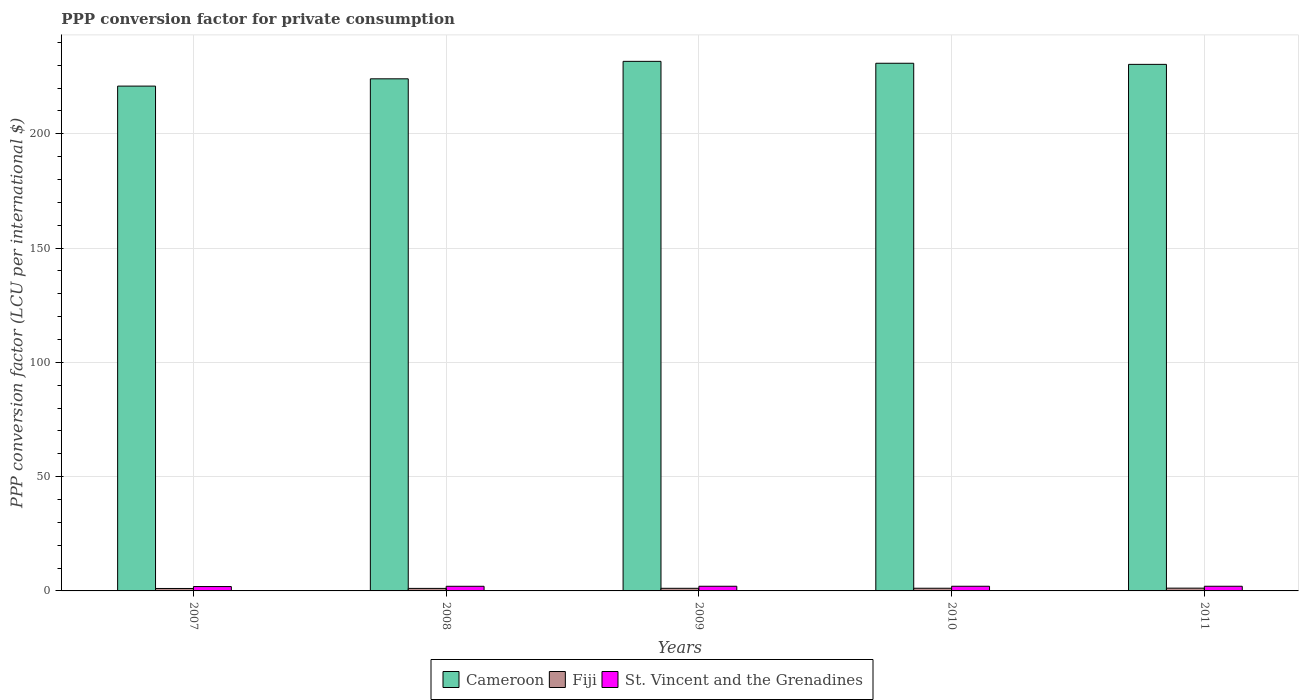How many different coloured bars are there?
Make the answer very short. 3. How many groups of bars are there?
Ensure brevity in your answer.  5. Are the number of bars per tick equal to the number of legend labels?
Provide a succinct answer. Yes. How many bars are there on the 2nd tick from the right?
Make the answer very short. 3. What is the label of the 3rd group of bars from the left?
Ensure brevity in your answer.  2009. What is the PPP conversion factor for private consumption in Fiji in 2011?
Offer a very short reply. 1.22. Across all years, what is the maximum PPP conversion factor for private consumption in Cameroon?
Offer a very short reply. 231.69. Across all years, what is the minimum PPP conversion factor for private consumption in Fiji?
Your answer should be compact. 1.07. In which year was the PPP conversion factor for private consumption in Cameroon minimum?
Provide a short and direct response. 2007. What is the total PPP conversion factor for private consumption in St. Vincent and the Grenadines in the graph?
Make the answer very short. 10.06. What is the difference between the PPP conversion factor for private consumption in Fiji in 2010 and that in 2011?
Your answer should be very brief. -0.05. What is the difference between the PPP conversion factor for private consumption in Fiji in 2008 and the PPP conversion factor for private consumption in Cameroon in 2010?
Give a very brief answer. -229.75. What is the average PPP conversion factor for private consumption in St. Vincent and the Grenadines per year?
Provide a succinct answer. 2.01. In the year 2008, what is the difference between the PPP conversion factor for private consumption in Cameroon and PPP conversion factor for private consumption in Fiji?
Make the answer very short. 222.94. What is the ratio of the PPP conversion factor for private consumption in St. Vincent and the Grenadines in 2010 to that in 2011?
Make the answer very short. 1. What is the difference between the highest and the second highest PPP conversion factor for private consumption in Cameroon?
Keep it short and to the point. 0.83. What is the difference between the highest and the lowest PPP conversion factor for private consumption in Cameroon?
Give a very brief answer. 10.83. In how many years, is the PPP conversion factor for private consumption in Fiji greater than the average PPP conversion factor for private consumption in Fiji taken over all years?
Ensure brevity in your answer.  3. What does the 1st bar from the left in 2010 represents?
Your answer should be compact. Cameroon. What does the 3rd bar from the right in 2011 represents?
Your answer should be compact. Cameroon. Are all the bars in the graph horizontal?
Provide a succinct answer. No. How many years are there in the graph?
Offer a very short reply. 5. Are the values on the major ticks of Y-axis written in scientific E-notation?
Your response must be concise. No. How are the legend labels stacked?
Offer a terse response. Horizontal. What is the title of the graph?
Keep it short and to the point. PPP conversion factor for private consumption. What is the label or title of the Y-axis?
Give a very brief answer. PPP conversion factor (LCU per international $). What is the PPP conversion factor (LCU per international $) in Cameroon in 2007?
Ensure brevity in your answer.  220.86. What is the PPP conversion factor (LCU per international $) of Fiji in 2007?
Ensure brevity in your answer.  1.07. What is the PPP conversion factor (LCU per international $) in St. Vincent and the Grenadines in 2007?
Provide a succinct answer. 1.91. What is the PPP conversion factor (LCU per international $) in Cameroon in 2008?
Offer a very short reply. 224.05. What is the PPP conversion factor (LCU per international $) in Fiji in 2008?
Your response must be concise. 1.11. What is the PPP conversion factor (LCU per international $) of St. Vincent and the Grenadines in 2008?
Provide a succinct answer. 2.03. What is the PPP conversion factor (LCU per international $) of Cameroon in 2009?
Offer a terse response. 231.69. What is the PPP conversion factor (LCU per international $) in Fiji in 2009?
Your answer should be very brief. 1.15. What is the PPP conversion factor (LCU per international $) of St. Vincent and the Grenadines in 2009?
Keep it short and to the point. 2.04. What is the PPP conversion factor (LCU per international $) of Cameroon in 2010?
Your answer should be compact. 230.86. What is the PPP conversion factor (LCU per international $) of Fiji in 2010?
Provide a succinct answer. 1.17. What is the PPP conversion factor (LCU per international $) of St. Vincent and the Grenadines in 2010?
Provide a succinct answer. 2.04. What is the PPP conversion factor (LCU per international $) in Cameroon in 2011?
Provide a short and direct response. 230.38. What is the PPP conversion factor (LCU per international $) in Fiji in 2011?
Your answer should be very brief. 1.22. What is the PPP conversion factor (LCU per international $) in St. Vincent and the Grenadines in 2011?
Your response must be concise. 2.04. Across all years, what is the maximum PPP conversion factor (LCU per international $) in Cameroon?
Give a very brief answer. 231.69. Across all years, what is the maximum PPP conversion factor (LCU per international $) in Fiji?
Ensure brevity in your answer.  1.22. Across all years, what is the maximum PPP conversion factor (LCU per international $) of St. Vincent and the Grenadines?
Provide a short and direct response. 2.04. Across all years, what is the minimum PPP conversion factor (LCU per international $) of Cameroon?
Give a very brief answer. 220.86. Across all years, what is the minimum PPP conversion factor (LCU per international $) in Fiji?
Keep it short and to the point. 1.07. Across all years, what is the minimum PPP conversion factor (LCU per international $) in St. Vincent and the Grenadines?
Provide a succinct answer. 1.91. What is the total PPP conversion factor (LCU per international $) of Cameroon in the graph?
Give a very brief answer. 1137.84. What is the total PPP conversion factor (LCU per international $) of Fiji in the graph?
Keep it short and to the point. 5.71. What is the total PPP conversion factor (LCU per international $) of St. Vincent and the Grenadines in the graph?
Make the answer very short. 10.06. What is the difference between the PPP conversion factor (LCU per international $) of Cameroon in 2007 and that in 2008?
Provide a short and direct response. -3.19. What is the difference between the PPP conversion factor (LCU per international $) in Fiji in 2007 and that in 2008?
Make the answer very short. -0.04. What is the difference between the PPP conversion factor (LCU per international $) in St. Vincent and the Grenadines in 2007 and that in 2008?
Provide a succinct answer. -0.11. What is the difference between the PPP conversion factor (LCU per international $) of Cameroon in 2007 and that in 2009?
Ensure brevity in your answer.  -10.83. What is the difference between the PPP conversion factor (LCU per international $) in Fiji in 2007 and that in 2009?
Offer a very short reply. -0.08. What is the difference between the PPP conversion factor (LCU per international $) of St. Vincent and the Grenadines in 2007 and that in 2009?
Provide a short and direct response. -0.13. What is the difference between the PPP conversion factor (LCU per international $) of Cameroon in 2007 and that in 2010?
Keep it short and to the point. -10. What is the difference between the PPP conversion factor (LCU per international $) of Fiji in 2007 and that in 2010?
Provide a short and direct response. -0.1. What is the difference between the PPP conversion factor (LCU per international $) in St. Vincent and the Grenadines in 2007 and that in 2010?
Your answer should be compact. -0.13. What is the difference between the PPP conversion factor (LCU per international $) of Cameroon in 2007 and that in 2011?
Offer a terse response. -9.51. What is the difference between the PPP conversion factor (LCU per international $) of Fiji in 2007 and that in 2011?
Keep it short and to the point. -0.15. What is the difference between the PPP conversion factor (LCU per international $) of St. Vincent and the Grenadines in 2007 and that in 2011?
Ensure brevity in your answer.  -0.13. What is the difference between the PPP conversion factor (LCU per international $) in Cameroon in 2008 and that in 2009?
Make the answer very short. -7.64. What is the difference between the PPP conversion factor (LCU per international $) in Fiji in 2008 and that in 2009?
Ensure brevity in your answer.  -0.04. What is the difference between the PPP conversion factor (LCU per international $) in St. Vincent and the Grenadines in 2008 and that in 2009?
Provide a succinct answer. -0.02. What is the difference between the PPP conversion factor (LCU per international $) of Cameroon in 2008 and that in 2010?
Your answer should be compact. -6.81. What is the difference between the PPP conversion factor (LCU per international $) in Fiji in 2008 and that in 2010?
Keep it short and to the point. -0.06. What is the difference between the PPP conversion factor (LCU per international $) in St. Vincent and the Grenadines in 2008 and that in 2010?
Your answer should be very brief. -0.01. What is the difference between the PPP conversion factor (LCU per international $) in Cameroon in 2008 and that in 2011?
Give a very brief answer. -6.33. What is the difference between the PPP conversion factor (LCU per international $) of Fiji in 2008 and that in 2011?
Give a very brief answer. -0.11. What is the difference between the PPP conversion factor (LCU per international $) of St. Vincent and the Grenadines in 2008 and that in 2011?
Your response must be concise. -0.01. What is the difference between the PPP conversion factor (LCU per international $) in Cameroon in 2009 and that in 2010?
Offer a terse response. 0.83. What is the difference between the PPP conversion factor (LCU per international $) in Fiji in 2009 and that in 2010?
Provide a succinct answer. -0.02. What is the difference between the PPP conversion factor (LCU per international $) in St. Vincent and the Grenadines in 2009 and that in 2010?
Provide a succinct answer. 0. What is the difference between the PPP conversion factor (LCU per international $) in Cameroon in 2009 and that in 2011?
Offer a very short reply. 1.32. What is the difference between the PPP conversion factor (LCU per international $) in Fiji in 2009 and that in 2011?
Keep it short and to the point. -0.07. What is the difference between the PPP conversion factor (LCU per international $) in St. Vincent and the Grenadines in 2009 and that in 2011?
Keep it short and to the point. 0. What is the difference between the PPP conversion factor (LCU per international $) in Cameroon in 2010 and that in 2011?
Give a very brief answer. 0.49. What is the difference between the PPP conversion factor (LCU per international $) of Fiji in 2010 and that in 2011?
Provide a short and direct response. -0.05. What is the difference between the PPP conversion factor (LCU per international $) in St. Vincent and the Grenadines in 2010 and that in 2011?
Give a very brief answer. -0. What is the difference between the PPP conversion factor (LCU per international $) of Cameroon in 2007 and the PPP conversion factor (LCU per international $) of Fiji in 2008?
Your answer should be very brief. 219.75. What is the difference between the PPP conversion factor (LCU per international $) of Cameroon in 2007 and the PPP conversion factor (LCU per international $) of St. Vincent and the Grenadines in 2008?
Offer a terse response. 218.84. What is the difference between the PPP conversion factor (LCU per international $) of Fiji in 2007 and the PPP conversion factor (LCU per international $) of St. Vincent and the Grenadines in 2008?
Give a very brief answer. -0.96. What is the difference between the PPP conversion factor (LCU per international $) in Cameroon in 2007 and the PPP conversion factor (LCU per international $) in Fiji in 2009?
Offer a terse response. 219.72. What is the difference between the PPP conversion factor (LCU per international $) in Cameroon in 2007 and the PPP conversion factor (LCU per international $) in St. Vincent and the Grenadines in 2009?
Your answer should be compact. 218.82. What is the difference between the PPP conversion factor (LCU per international $) in Fiji in 2007 and the PPP conversion factor (LCU per international $) in St. Vincent and the Grenadines in 2009?
Give a very brief answer. -0.97. What is the difference between the PPP conversion factor (LCU per international $) in Cameroon in 2007 and the PPP conversion factor (LCU per international $) in Fiji in 2010?
Make the answer very short. 219.69. What is the difference between the PPP conversion factor (LCU per international $) of Cameroon in 2007 and the PPP conversion factor (LCU per international $) of St. Vincent and the Grenadines in 2010?
Offer a very short reply. 218.82. What is the difference between the PPP conversion factor (LCU per international $) in Fiji in 2007 and the PPP conversion factor (LCU per international $) in St. Vincent and the Grenadines in 2010?
Your answer should be compact. -0.97. What is the difference between the PPP conversion factor (LCU per international $) of Cameroon in 2007 and the PPP conversion factor (LCU per international $) of Fiji in 2011?
Provide a short and direct response. 219.65. What is the difference between the PPP conversion factor (LCU per international $) of Cameroon in 2007 and the PPP conversion factor (LCU per international $) of St. Vincent and the Grenadines in 2011?
Keep it short and to the point. 218.82. What is the difference between the PPP conversion factor (LCU per international $) of Fiji in 2007 and the PPP conversion factor (LCU per international $) of St. Vincent and the Grenadines in 2011?
Your answer should be compact. -0.97. What is the difference between the PPP conversion factor (LCU per international $) of Cameroon in 2008 and the PPP conversion factor (LCU per international $) of Fiji in 2009?
Your response must be concise. 222.9. What is the difference between the PPP conversion factor (LCU per international $) of Cameroon in 2008 and the PPP conversion factor (LCU per international $) of St. Vincent and the Grenadines in 2009?
Offer a terse response. 222.01. What is the difference between the PPP conversion factor (LCU per international $) in Fiji in 2008 and the PPP conversion factor (LCU per international $) in St. Vincent and the Grenadines in 2009?
Your response must be concise. -0.93. What is the difference between the PPP conversion factor (LCU per international $) in Cameroon in 2008 and the PPP conversion factor (LCU per international $) in Fiji in 2010?
Offer a very short reply. 222.88. What is the difference between the PPP conversion factor (LCU per international $) of Cameroon in 2008 and the PPP conversion factor (LCU per international $) of St. Vincent and the Grenadines in 2010?
Your response must be concise. 222.01. What is the difference between the PPP conversion factor (LCU per international $) in Fiji in 2008 and the PPP conversion factor (LCU per international $) in St. Vincent and the Grenadines in 2010?
Give a very brief answer. -0.93. What is the difference between the PPP conversion factor (LCU per international $) of Cameroon in 2008 and the PPP conversion factor (LCU per international $) of Fiji in 2011?
Provide a short and direct response. 222.83. What is the difference between the PPP conversion factor (LCU per international $) in Cameroon in 2008 and the PPP conversion factor (LCU per international $) in St. Vincent and the Grenadines in 2011?
Keep it short and to the point. 222.01. What is the difference between the PPP conversion factor (LCU per international $) of Fiji in 2008 and the PPP conversion factor (LCU per international $) of St. Vincent and the Grenadines in 2011?
Ensure brevity in your answer.  -0.93. What is the difference between the PPP conversion factor (LCU per international $) in Cameroon in 2009 and the PPP conversion factor (LCU per international $) in Fiji in 2010?
Ensure brevity in your answer.  230.52. What is the difference between the PPP conversion factor (LCU per international $) of Cameroon in 2009 and the PPP conversion factor (LCU per international $) of St. Vincent and the Grenadines in 2010?
Your answer should be very brief. 229.65. What is the difference between the PPP conversion factor (LCU per international $) in Fiji in 2009 and the PPP conversion factor (LCU per international $) in St. Vincent and the Grenadines in 2010?
Your answer should be very brief. -0.89. What is the difference between the PPP conversion factor (LCU per international $) of Cameroon in 2009 and the PPP conversion factor (LCU per international $) of Fiji in 2011?
Give a very brief answer. 230.48. What is the difference between the PPP conversion factor (LCU per international $) of Cameroon in 2009 and the PPP conversion factor (LCU per international $) of St. Vincent and the Grenadines in 2011?
Keep it short and to the point. 229.65. What is the difference between the PPP conversion factor (LCU per international $) in Fiji in 2009 and the PPP conversion factor (LCU per international $) in St. Vincent and the Grenadines in 2011?
Keep it short and to the point. -0.89. What is the difference between the PPP conversion factor (LCU per international $) of Cameroon in 2010 and the PPP conversion factor (LCU per international $) of Fiji in 2011?
Keep it short and to the point. 229.64. What is the difference between the PPP conversion factor (LCU per international $) of Cameroon in 2010 and the PPP conversion factor (LCU per international $) of St. Vincent and the Grenadines in 2011?
Ensure brevity in your answer.  228.82. What is the difference between the PPP conversion factor (LCU per international $) in Fiji in 2010 and the PPP conversion factor (LCU per international $) in St. Vincent and the Grenadines in 2011?
Your answer should be compact. -0.87. What is the average PPP conversion factor (LCU per international $) of Cameroon per year?
Ensure brevity in your answer.  227.57. What is the average PPP conversion factor (LCU per international $) of Fiji per year?
Provide a succinct answer. 1.14. What is the average PPP conversion factor (LCU per international $) in St. Vincent and the Grenadines per year?
Your response must be concise. 2.01. In the year 2007, what is the difference between the PPP conversion factor (LCU per international $) in Cameroon and PPP conversion factor (LCU per international $) in Fiji?
Provide a short and direct response. 219.79. In the year 2007, what is the difference between the PPP conversion factor (LCU per international $) in Cameroon and PPP conversion factor (LCU per international $) in St. Vincent and the Grenadines?
Your answer should be very brief. 218.95. In the year 2007, what is the difference between the PPP conversion factor (LCU per international $) in Fiji and PPP conversion factor (LCU per international $) in St. Vincent and the Grenadines?
Provide a succinct answer. -0.84. In the year 2008, what is the difference between the PPP conversion factor (LCU per international $) in Cameroon and PPP conversion factor (LCU per international $) in Fiji?
Provide a short and direct response. 222.94. In the year 2008, what is the difference between the PPP conversion factor (LCU per international $) of Cameroon and PPP conversion factor (LCU per international $) of St. Vincent and the Grenadines?
Your response must be concise. 222.02. In the year 2008, what is the difference between the PPP conversion factor (LCU per international $) in Fiji and PPP conversion factor (LCU per international $) in St. Vincent and the Grenadines?
Ensure brevity in your answer.  -0.92. In the year 2009, what is the difference between the PPP conversion factor (LCU per international $) of Cameroon and PPP conversion factor (LCU per international $) of Fiji?
Provide a succinct answer. 230.55. In the year 2009, what is the difference between the PPP conversion factor (LCU per international $) in Cameroon and PPP conversion factor (LCU per international $) in St. Vincent and the Grenadines?
Your answer should be compact. 229.65. In the year 2009, what is the difference between the PPP conversion factor (LCU per international $) of Fiji and PPP conversion factor (LCU per international $) of St. Vincent and the Grenadines?
Give a very brief answer. -0.9. In the year 2010, what is the difference between the PPP conversion factor (LCU per international $) in Cameroon and PPP conversion factor (LCU per international $) in Fiji?
Provide a succinct answer. 229.69. In the year 2010, what is the difference between the PPP conversion factor (LCU per international $) in Cameroon and PPP conversion factor (LCU per international $) in St. Vincent and the Grenadines?
Keep it short and to the point. 228.82. In the year 2010, what is the difference between the PPP conversion factor (LCU per international $) in Fiji and PPP conversion factor (LCU per international $) in St. Vincent and the Grenadines?
Your answer should be very brief. -0.87. In the year 2011, what is the difference between the PPP conversion factor (LCU per international $) of Cameroon and PPP conversion factor (LCU per international $) of Fiji?
Give a very brief answer. 229.16. In the year 2011, what is the difference between the PPP conversion factor (LCU per international $) of Cameroon and PPP conversion factor (LCU per international $) of St. Vincent and the Grenadines?
Your answer should be compact. 228.34. In the year 2011, what is the difference between the PPP conversion factor (LCU per international $) of Fiji and PPP conversion factor (LCU per international $) of St. Vincent and the Grenadines?
Ensure brevity in your answer.  -0.82. What is the ratio of the PPP conversion factor (LCU per international $) in Cameroon in 2007 to that in 2008?
Offer a very short reply. 0.99. What is the ratio of the PPP conversion factor (LCU per international $) in Fiji in 2007 to that in 2008?
Keep it short and to the point. 0.96. What is the ratio of the PPP conversion factor (LCU per international $) in St. Vincent and the Grenadines in 2007 to that in 2008?
Ensure brevity in your answer.  0.94. What is the ratio of the PPP conversion factor (LCU per international $) in Cameroon in 2007 to that in 2009?
Keep it short and to the point. 0.95. What is the ratio of the PPP conversion factor (LCU per international $) of Fiji in 2007 to that in 2009?
Offer a terse response. 0.93. What is the ratio of the PPP conversion factor (LCU per international $) in St. Vincent and the Grenadines in 2007 to that in 2009?
Offer a terse response. 0.94. What is the ratio of the PPP conversion factor (LCU per international $) in Cameroon in 2007 to that in 2010?
Give a very brief answer. 0.96. What is the ratio of the PPP conversion factor (LCU per international $) of Fiji in 2007 to that in 2010?
Provide a succinct answer. 0.91. What is the ratio of the PPP conversion factor (LCU per international $) in St. Vincent and the Grenadines in 2007 to that in 2010?
Provide a succinct answer. 0.94. What is the ratio of the PPP conversion factor (LCU per international $) of Cameroon in 2007 to that in 2011?
Make the answer very short. 0.96. What is the ratio of the PPP conversion factor (LCU per international $) of Fiji in 2007 to that in 2011?
Provide a succinct answer. 0.88. What is the ratio of the PPP conversion factor (LCU per international $) of St. Vincent and the Grenadines in 2007 to that in 2011?
Make the answer very short. 0.94. What is the ratio of the PPP conversion factor (LCU per international $) of Cameroon in 2008 to that in 2009?
Make the answer very short. 0.97. What is the ratio of the PPP conversion factor (LCU per international $) in Fiji in 2008 to that in 2009?
Ensure brevity in your answer.  0.97. What is the ratio of the PPP conversion factor (LCU per international $) of St. Vincent and the Grenadines in 2008 to that in 2009?
Your answer should be very brief. 0.99. What is the ratio of the PPP conversion factor (LCU per international $) of Cameroon in 2008 to that in 2010?
Offer a terse response. 0.97. What is the ratio of the PPP conversion factor (LCU per international $) in Fiji in 2008 to that in 2010?
Provide a short and direct response. 0.95. What is the ratio of the PPP conversion factor (LCU per international $) in Cameroon in 2008 to that in 2011?
Your answer should be compact. 0.97. What is the ratio of the PPP conversion factor (LCU per international $) of Fiji in 2008 to that in 2011?
Your answer should be compact. 0.91. What is the ratio of the PPP conversion factor (LCU per international $) in St. Vincent and the Grenadines in 2008 to that in 2011?
Provide a short and direct response. 0.99. What is the ratio of the PPP conversion factor (LCU per international $) in Fiji in 2009 to that in 2010?
Ensure brevity in your answer.  0.98. What is the ratio of the PPP conversion factor (LCU per international $) in Fiji in 2009 to that in 2011?
Provide a short and direct response. 0.94. What is the ratio of the PPP conversion factor (LCU per international $) in St. Vincent and the Grenadines in 2009 to that in 2011?
Make the answer very short. 1. What is the ratio of the PPP conversion factor (LCU per international $) in Cameroon in 2010 to that in 2011?
Make the answer very short. 1. What is the ratio of the PPP conversion factor (LCU per international $) in Fiji in 2010 to that in 2011?
Your answer should be compact. 0.96. What is the ratio of the PPP conversion factor (LCU per international $) in St. Vincent and the Grenadines in 2010 to that in 2011?
Offer a terse response. 1. What is the difference between the highest and the second highest PPP conversion factor (LCU per international $) in Cameroon?
Keep it short and to the point. 0.83. What is the difference between the highest and the second highest PPP conversion factor (LCU per international $) of Fiji?
Your answer should be very brief. 0.05. What is the difference between the highest and the second highest PPP conversion factor (LCU per international $) of St. Vincent and the Grenadines?
Keep it short and to the point. 0. What is the difference between the highest and the lowest PPP conversion factor (LCU per international $) of Cameroon?
Ensure brevity in your answer.  10.83. What is the difference between the highest and the lowest PPP conversion factor (LCU per international $) of Fiji?
Offer a very short reply. 0.15. What is the difference between the highest and the lowest PPP conversion factor (LCU per international $) of St. Vincent and the Grenadines?
Your answer should be very brief. 0.13. 